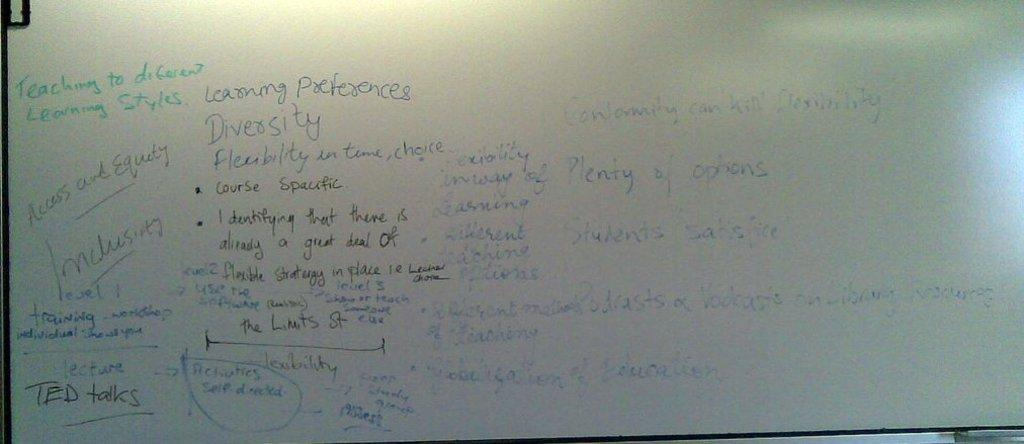Provide a one-sentence caption for the provided image. A whiteboard has a green note that says "teaching to different learning styles". 